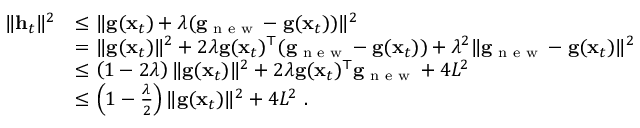<formula> <loc_0><loc_0><loc_500><loc_500>\begin{array} { r l } { \| { \mathbf h _ { t } } \| ^ { 2 } } & { \leq \| { \mathbf g ( \mathbf x _ { t } ) + \lambda ( \mathbf g _ { n e w } - \mathbf g ( \mathbf x _ { t } ) ) } \| ^ { 2 } } \\ & { = \| \mathbf g ( \mathbf x _ { t } ) \| ^ { 2 } + 2 \lambda \mathbf g ( \mathbf x _ { t } ) ^ { \top } ( \mathbf g _ { n e w } - \mathbf g ( \mathbf x _ { t } ) ) + \lambda ^ { 2 } \| \mathbf g _ { n e w } - \mathbf g ( \mathbf x _ { t } ) \| ^ { 2 } } \\ & { \leq \left ( 1 - 2 \lambda \right ) \| \mathbf g ( \mathbf x _ { t } ) \| ^ { 2 } + 2 \lambda \mathbf g ( \mathbf x _ { t } ) ^ { \top } \mathbf g _ { n e w } + 4 L ^ { 2 } } \\ & { \leq \left ( 1 - \frac { \lambda } { 2 } \right ) \| \mathbf g ( \mathbf x _ { t } ) \| ^ { 2 } + 4 L ^ { 2 } . } \end{array}</formula> 